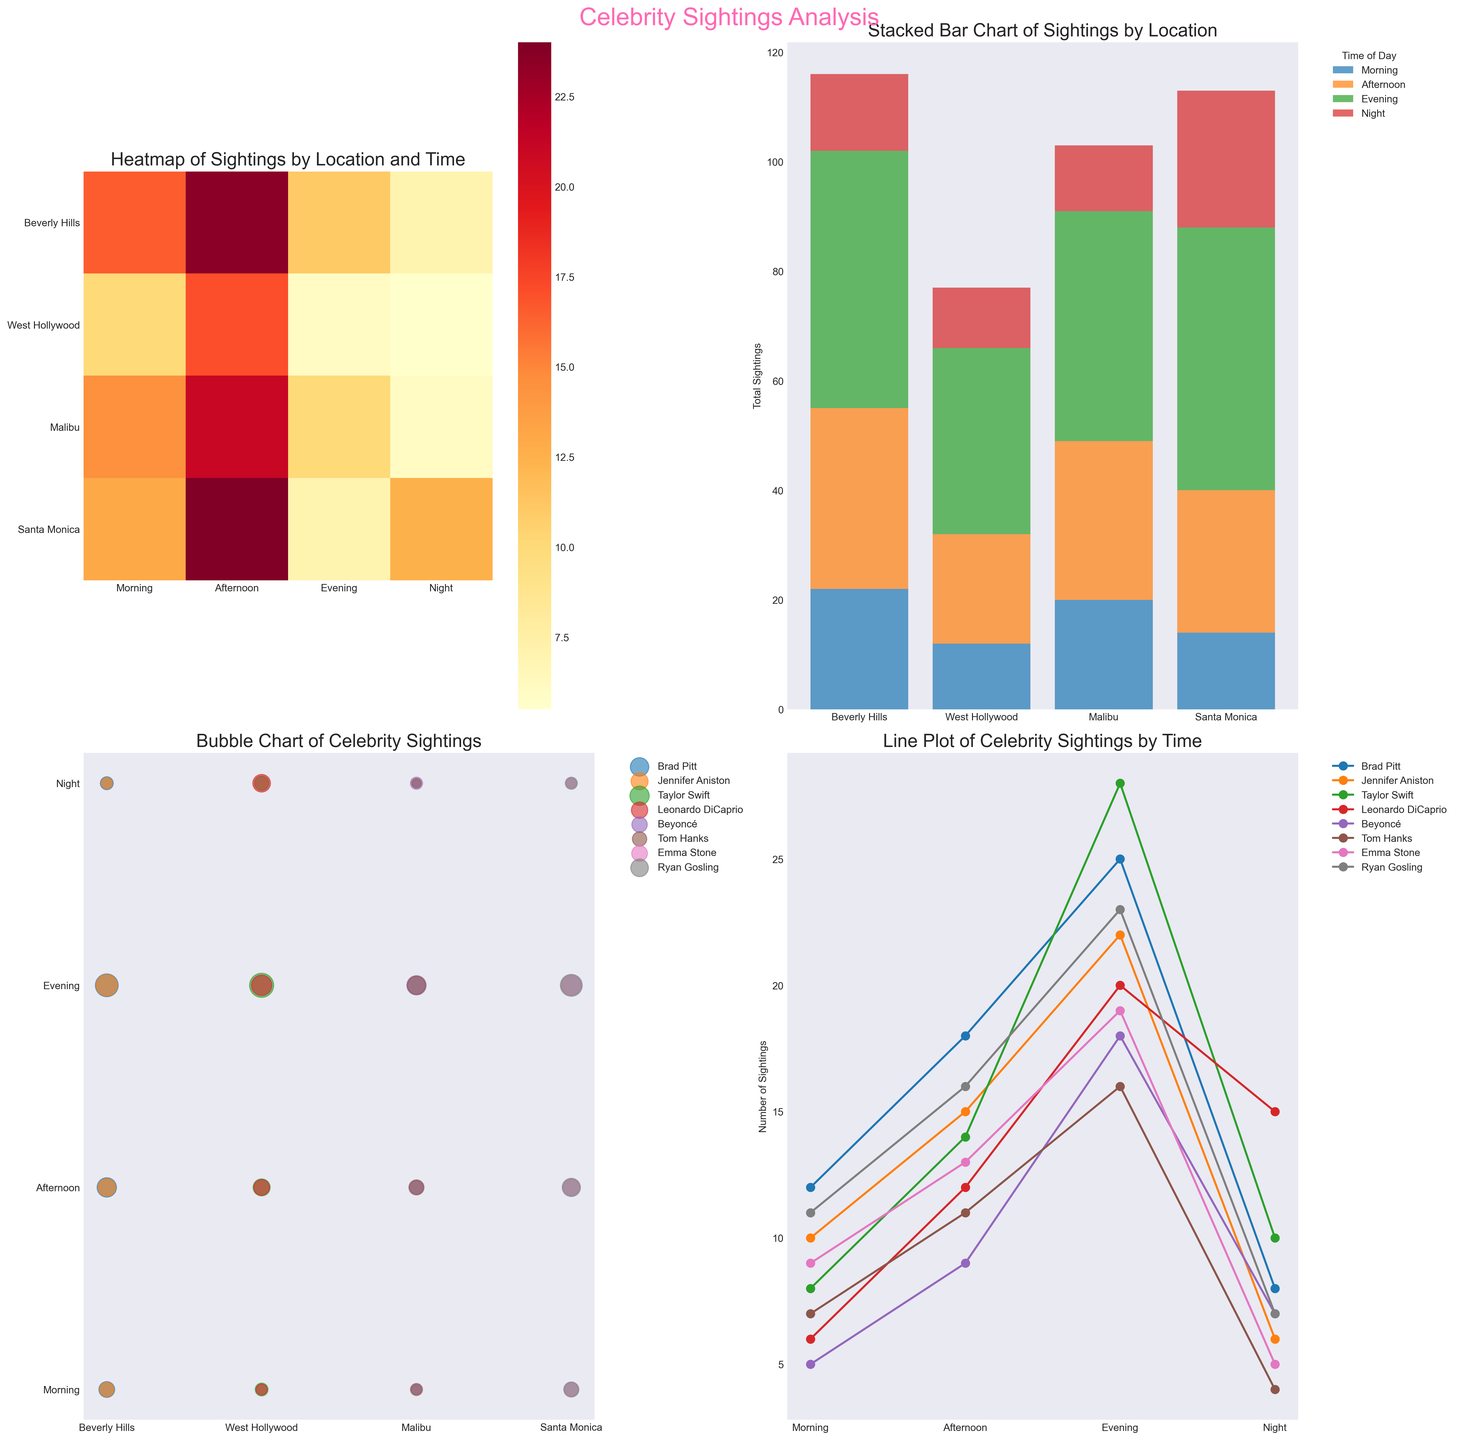What time of day has the fewest sightings in West Hollywood? From the heatmap, the lightest color in West Hollywood is during the morning. Count the values in the bubble chart at the morning row for West Hollywood locations: (8 + 6) = 14
Answer: Morning Which location has the highest total sightings during the evening based on the stacked bar chart? Look at the stacked bar values for the evening bar section. Beverly Hills has the highest stacked height for evening sightings.
Answer: Beverly Hills Comparing morning sightings, is Beyoncé's sightings in Malibu higher or lower than Ryan Gosling's in Santa Monica? From the bubble chart, Beyoncés sightings for Malibu in the morning is indicated by the bubble size. It is 5. Ryan Gosling's in Santa Monica is 11.
Answer: Lower How many total sightings are there in Beverly Hills during the night? Sum the values from the stacked bar chart of Beverly Hills for the night section. Brad Pitt (8) + Jennifer Aniston (6) = 14
Answer: 14 What is the average number of sightings in Beverly Hills during the afternoon? Look at the line plot values for each celebrity in the afternoon slot in Beverly Hills. Brad Pitt (18) + Jennifer Aniston (15) = 33. Divide by 2 (number of celebrities) = 33 / 2 = 16.5
Answer: 16.5 Which celebrity had the most sightings in West Hollywood during the night? Check the line plot for night sightings. Leonardo DiCaprio has the highest value, 15, in the night for West Hollywood location.
Answer: Leonardo DiCaprio Is Brad Pitt's sighting in the morning in Beverly Hills more or less than Taylor Swift's in the afternoon in West Hollywood? From the bubble chart, Brad Pitt's sightings in the morning is 12 and Taylor Swift's in the afternoon is 14.
Answer: Less What is the difference in total sightings between the afternoon and evening in Santa Monica? Check the stacked bar chart. The afternoon value for Santa Monica is (Emma Stone 13 + Ryan Gosling 16) = 29 and the evening is (Emma Stone 19 + Ryan Gosling 23) = 42. Difference = 42 - 29 = 13
Answer: 13 Which celebrity shows the most variation in their sightings across different times of day? Look at the line plot. Taylor Swift's vertical distance varies widely, from 8 to 28, indicating the most variation across different times of day.
Answer: Taylor Swift 